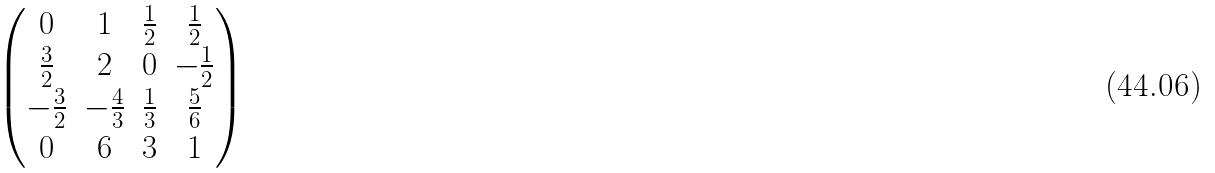<formula> <loc_0><loc_0><loc_500><loc_500>\begin{pmatrix} 0 & 1 & \frac { 1 } { 2 } & \frac { 1 } { 2 } \\ \frac { 3 } { 2 } & 2 & 0 & - \frac { 1 } { 2 } \\ - \frac { 3 } { 2 } & - \frac { 4 } { 3 } & \frac { 1 } { 3 } & \frac { 5 } { 6 } \\ 0 & 6 & 3 & 1 \end{pmatrix}</formula> 